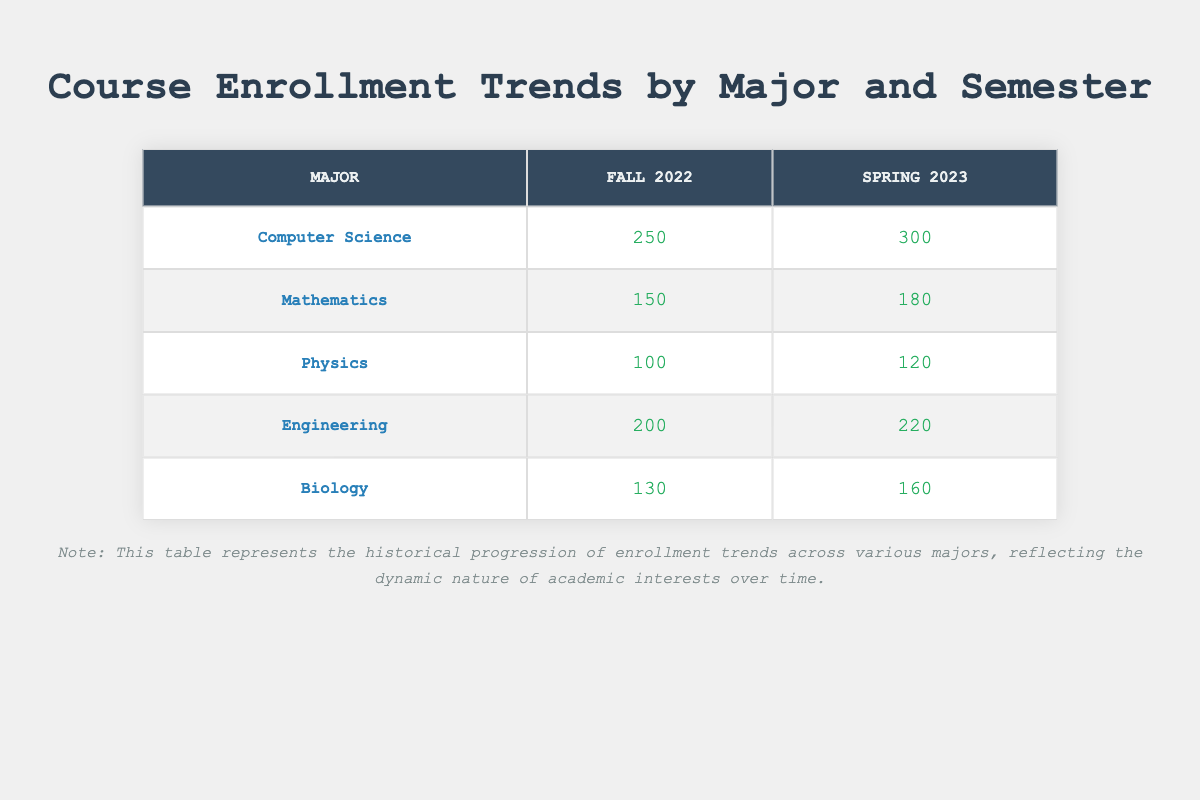What is the enrollment number for Computer Science in Spring 2023? The table indicates that for the major Computer Science, the enrollment number in Spring 2023 is recorded as 300.
Answer: 300 Which major had the lowest enrollment in Fall 2022? By examining the Fall 2022 row, Physics has the lowest enrollment with a count of 100, compared to other majors: Computer Science (250), Mathematics (150), Engineering (200), and Biology (130).
Answer: Physics What is the total enrollment for Engineering over the two semesters? To find the total for Engineering, add the enrollment numbers for Fall 2022 (200) and Spring 2023 (220), giving us 200 + 220 = 420.
Answer: 420 Was there an increase in enrollment for Mathematics from Fall 2022 to Spring 2023? The enrollment for Mathematics in Fall 2022 was 150 and increased to 180 in Spring 2023. Thus, there was an increase as 180 is greater than 150.
Answer: Yes What is the average enrollment across all majors in Spring 2023? First, sum the enrollments for each major in Spring 2023: Computer Science (300) + Mathematics (180) + Physics (120) + Engineering (220) + Biology (160) = 1,080. Since there are 5 majors, divide the total by 5: 1080 / 5 = 216.
Answer: 216 How much did the enrollment for Biology increase from Fall 2022 to Spring 2023? For Biology, the enrollment increased from 130 in Fall 2022 to 160 in Spring 2023. The difference can be calculated as 160 - 130 = 30.
Answer: 30 Which major saw the greatest increase in enrollment from Fall 2022 to Spring 2023? By calculating the changes: Computer Science (+50), Mathematics (+30), Physics (+20), Engineering (+20), and Biology (+30), it's clear that Computer Science experienced the highest increase of 50.
Answer: Computer Science Is the enrollment for Physics in Spring 2023 more than that of Biology in Fall 2022? In Spring 2023, Physics had an enrollment of 120 while Biology's enrollment in Fall 2022 was 130. Since 120 is less than 130, the statement is false.
Answer: No What is the total enrollment for all majors in Fall 2022? Adding all major enrollments for Fall 2022: Computer Science (250) + Mathematics (150) + Physics (100) + Engineering (200) + Biology (130) gives a total of 250 + 150 + 100 + 200 + 130 = 830.
Answer: 830 